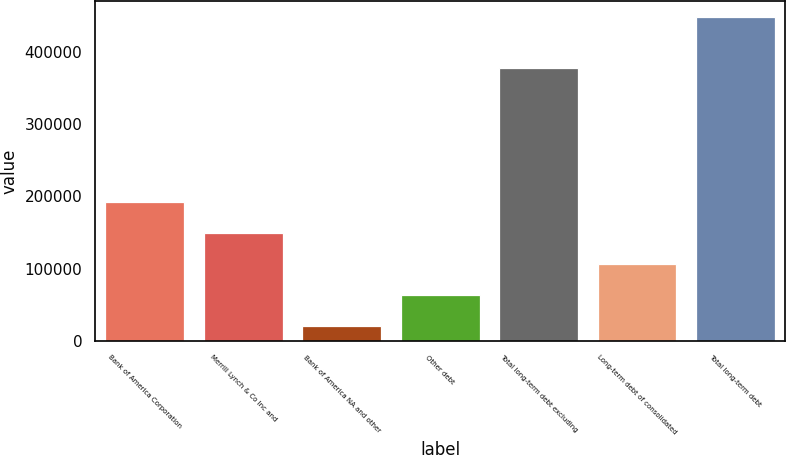Convert chart to OTSL. <chart><loc_0><loc_0><loc_500><loc_500><bar_chart><fcel>Bank of America Corporation<fcel>Merrill Lynch & Co Inc and<fcel>Bank of America NA and other<fcel>Other debt<fcel>Total long-term debt excluding<fcel>Long-term debt of consolidated<fcel>Total long-term debt<nl><fcel>192133<fcel>149416<fcel>21267<fcel>63983.4<fcel>377418<fcel>106700<fcel>448431<nl></chart> 